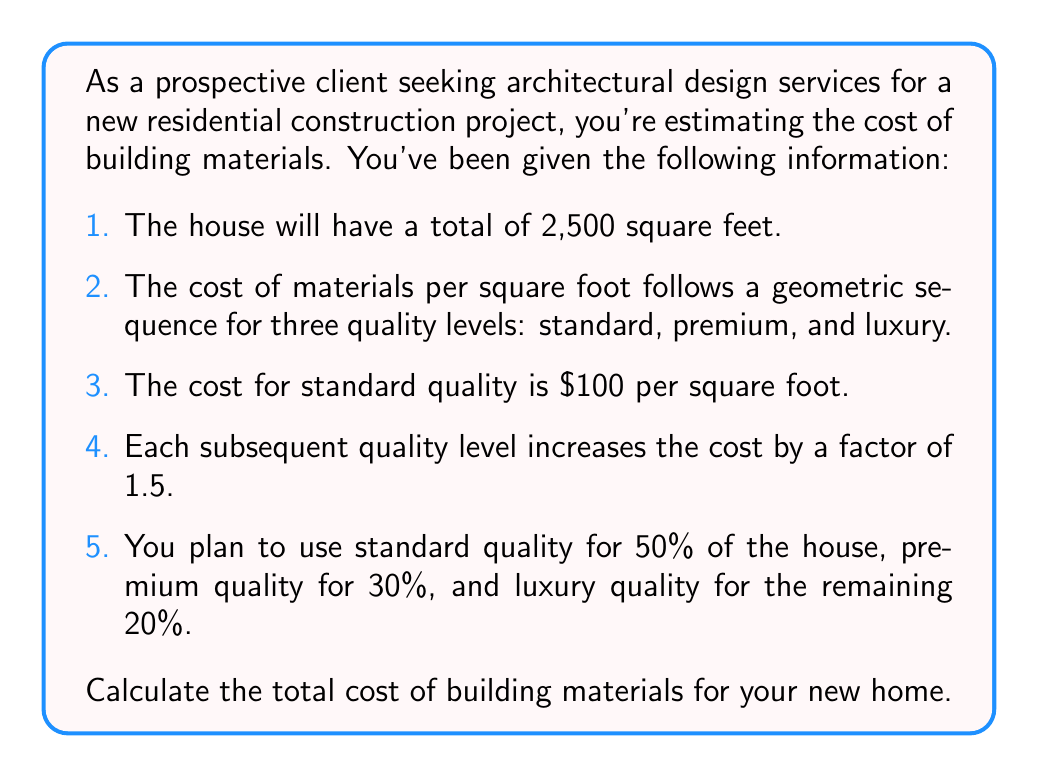Help me with this question. Let's approach this problem step by step:

1. First, we need to determine the cost per square foot for each quality level. We're given that this follows a geometric sequence with a common ratio of 1.5.

   Standard: $a_1 = $100 per sq ft
   Premium: $a_2 = a_1 \cdot 1.5 = 100 \cdot 1.5 = $150 per sq ft
   Luxury: $a_3 = a_2 \cdot 1.5 = 150 \cdot 1.5 = $225 per sq ft

2. Now, let's calculate the square footage for each quality level:

   Standard: $50\% \text{ of } 2,500 = 0.5 \cdot 2,500 = 1,250 \text{ sq ft}$
   Premium: $30\% \text{ of } 2,500 = 0.3 \cdot 2,500 = 750 \text{ sq ft}$
   Luxury: $20\% \text{ of } 2,500 = 0.2 \cdot 2,500 = 500 \text{ sq ft}$

3. Next, we'll calculate the cost for each quality level:

   Standard: $1,250 \text{ sq ft} \cdot $100/\text{sq ft} = $125,000$
   Premium: $750 \text{ sq ft} \cdot $150/\text{sq ft} = $112,500$
   Luxury: $500 \text{ sq ft} \cdot $225/\text{sq ft} = $112,500$

4. Finally, we sum up the costs for all quality levels:

   Total Cost = $125,000 + $112,500 + $112,500 = $350,000$

Therefore, the total cost of building materials for your new home is $350,000.
Answer: $350,000 